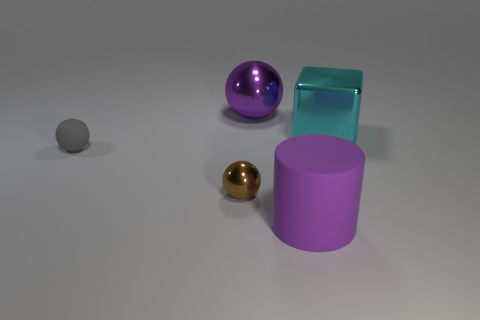How many other objects are the same color as the large matte cylinder? There is one object that shares the color with the large matte cylinder. It is the sphere to the right of the cylinder. The color match is a nice touch in this collection of objects, providing a sense of harmony amidst the variety. 